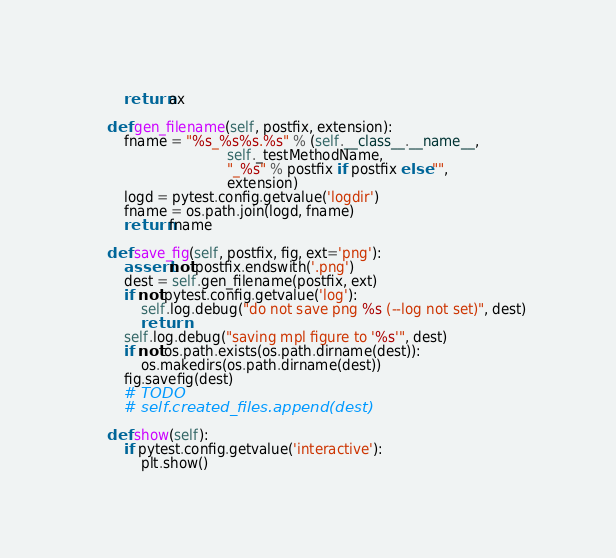Convert code to text. <code><loc_0><loc_0><loc_500><loc_500><_Python_>        return ax

    def gen_filename(self, postfix, extension):
        fname = "%s_%s%s.%s" % (self.__class__.__name__,
                                self._testMethodName,
                                "_%s" % postfix if postfix else "",
                                extension)
        logd = pytest.config.getvalue('logdir')
        fname = os.path.join(logd, fname)
        return fname

    def save_fig(self, postfix, fig, ext='png'):
        assert not postfix.endswith('.png')
        dest = self.gen_filename(postfix, ext)
        if not pytest.config.getvalue('log'):
            self.log.debug("do not save png %s (--log not set)", dest)
            return
        self.log.debug("saving mpl figure to '%s'", dest)
        if not os.path.exists(os.path.dirname(dest)):
            os.makedirs(os.path.dirname(dest))
        fig.savefig(dest)
        # TODO
        # self.created_files.append(dest)

    def show(self):
        if pytest.config.getvalue('interactive'):
            plt.show()
</code> 